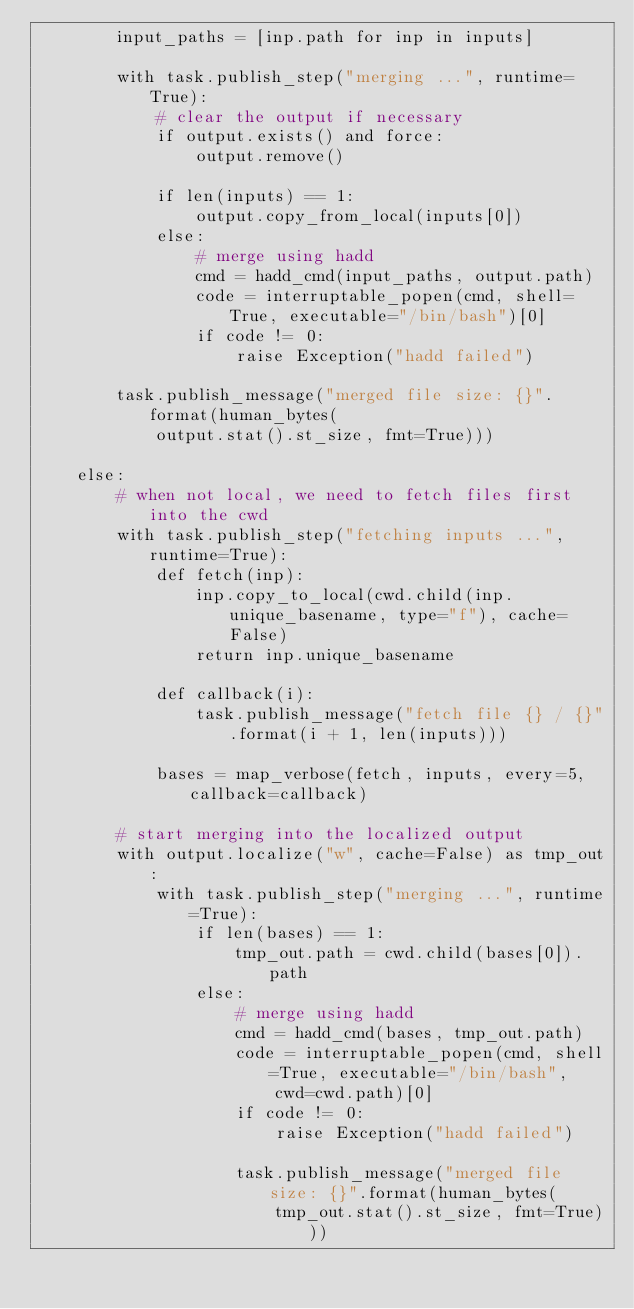Convert code to text. <code><loc_0><loc_0><loc_500><loc_500><_Python_>        input_paths = [inp.path for inp in inputs]

        with task.publish_step("merging ...", runtime=True):
            # clear the output if necessary
            if output.exists() and force:
                output.remove()

            if len(inputs) == 1:
                output.copy_from_local(inputs[0])
            else:
                # merge using hadd
                cmd = hadd_cmd(input_paths, output.path)
                code = interruptable_popen(cmd, shell=True, executable="/bin/bash")[0]
                if code != 0:
                    raise Exception("hadd failed")

        task.publish_message("merged file size: {}".format(human_bytes(
            output.stat().st_size, fmt=True)))

    else:
        # when not local, we need to fetch files first into the cwd
        with task.publish_step("fetching inputs ...", runtime=True):
            def fetch(inp):
                inp.copy_to_local(cwd.child(inp.unique_basename, type="f"), cache=False)
                return inp.unique_basename

            def callback(i):
                task.publish_message("fetch file {} / {}".format(i + 1, len(inputs)))

            bases = map_verbose(fetch, inputs, every=5, callback=callback)

        # start merging into the localized output
        with output.localize("w", cache=False) as tmp_out:
            with task.publish_step("merging ...", runtime=True):
                if len(bases) == 1:
                    tmp_out.path = cwd.child(bases[0]).path
                else:
                    # merge using hadd
                    cmd = hadd_cmd(bases, tmp_out.path)
                    code = interruptable_popen(cmd, shell=True, executable="/bin/bash",
                        cwd=cwd.path)[0]
                    if code != 0:
                        raise Exception("hadd failed")

                    task.publish_message("merged file size: {}".format(human_bytes(
                        tmp_out.stat().st_size, fmt=True)))
</code> 